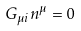Convert formula to latex. <formula><loc_0><loc_0><loc_500><loc_500>G _ { \mu i } n ^ { \mu } = 0</formula> 